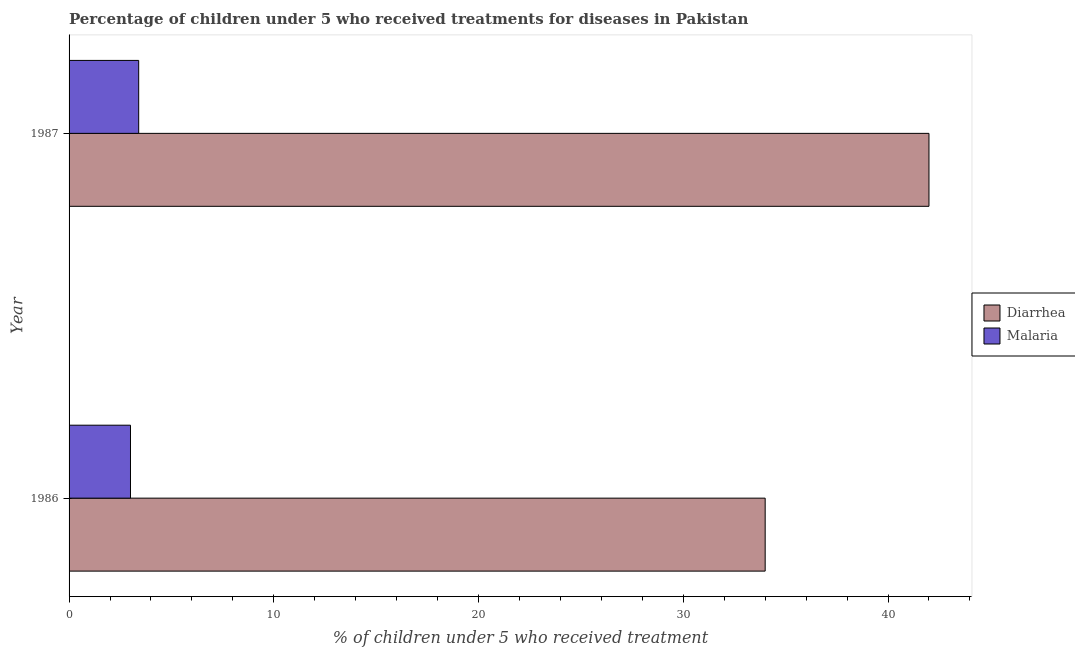How many different coloured bars are there?
Your answer should be compact. 2. How many bars are there on the 2nd tick from the top?
Offer a terse response. 2. What is the percentage of children who received treatment for malaria in 1987?
Your answer should be compact. 3.4. Across all years, what is the maximum percentage of children who received treatment for diarrhoea?
Your answer should be compact. 42. Across all years, what is the minimum percentage of children who received treatment for diarrhoea?
Provide a short and direct response. 34. In which year was the percentage of children who received treatment for malaria minimum?
Give a very brief answer. 1986. What is the total percentage of children who received treatment for diarrhoea in the graph?
Your answer should be very brief. 76. What is the difference between the percentage of children who received treatment for diarrhoea in 1986 and that in 1987?
Offer a very short reply. -8. What is the difference between the percentage of children who received treatment for malaria in 1987 and the percentage of children who received treatment for diarrhoea in 1986?
Make the answer very short. -30.6. What is the average percentage of children who received treatment for malaria per year?
Your answer should be very brief. 3.2. In the year 1986, what is the difference between the percentage of children who received treatment for malaria and percentage of children who received treatment for diarrhoea?
Keep it short and to the point. -31. In how many years, is the percentage of children who received treatment for diarrhoea greater than 40 %?
Keep it short and to the point. 1. What is the ratio of the percentage of children who received treatment for malaria in 1986 to that in 1987?
Provide a short and direct response. 0.88. Is the percentage of children who received treatment for diarrhoea in 1986 less than that in 1987?
Provide a succinct answer. Yes. In how many years, is the percentage of children who received treatment for malaria greater than the average percentage of children who received treatment for malaria taken over all years?
Provide a short and direct response. 1. What does the 1st bar from the top in 1986 represents?
Offer a very short reply. Malaria. What does the 1st bar from the bottom in 1987 represents?
Offer a very short reply. Diarrhea. How many bars are there?
Offer a very short reply. 4. Are all the bars in the graph horizontal?
Provide a succinct answer. Yes. How many years are there in the graph?
Offer a very short reply. 2. What is the difference between two consecutive major ticks on the X-axis?
Provide a succinct answer. 10. Are the values on the major ticks of X-axis written in scientific E-notation?
Give a very brief answer. No. How many legend labels are there?
Provide a succinct answer. 2. What is the title of the graph?
Keep it short and to the point. Percentage of children under 5 who received treatments for diseases in Pakistan. Does "Forest" appear as one of the legend labels in the graph?
Provide a short and direct response. No. What is the label or title of the X-axis?
Provide a short and direct response. % of children under 5 who received treatment. What is the label or title of the Y-axis?
Offer a terse response. Year. What is the % of children under 5 who received treatment in Malaria in 1986?
Offer a very short reply. 3. What is the % of children under 5 who received treatment in Diarrhea in 1987?
Your response must be concise. 42. Across all years, what is the minimum % of children under 5 who received treatment in Diarrhea?
Offer a very short reply. 34. What is the total % of children under 5 who received treatment in Malaria in the graph?
Offer a terse response. 6.4. What is the difference between the % of children under 5 who received treatment of Diarrhea in 1986 and the % of children under 5 who received treatment of Malaria in 1987?
Offer a terse response. 30.6. What is the average % of children under 5 who received treatment of Diarrhea per year?
Your answer should be compact. 38. In the year 1986, what is the difference between the % of children under 5 who received treatment in Diarrhea and % of children under 5 who received treatment in Malaria?
Provide a succinct answer. 31. In the year 1987, what is the difference between the % of children under 5 who received treatment in Diarrhea and % of children under 5 who received treatment in Malaria?
Your answer should be compact. 38.6. What is the ratio of the % of children under 5 who received treatment of Diarrhea in 1986 to that in 1987?
Your answer should be compact. 0.81. What is the ratio of the % of children under 5 who received treatment of Malaria in 1986 to that in 1987?
Offer a very short reply. 0.88. What is the difference between the highest and the lowest % of children under 5 who received treatment in Diarrhea?
Offer a terse response. 8. What is the difference between the highest and the lowest % of children under 5 who received treatment of Malaria?
Your answer should be compact. 0.4. 